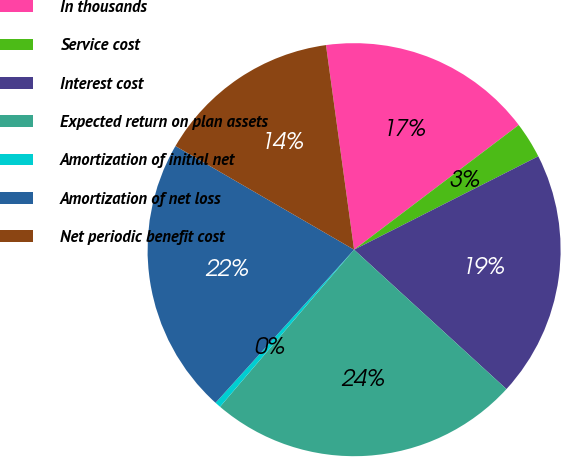Convert chart. <chart><loc_0><loc_0><loc_500><loc_500><pie_chart><fcel>In thousands<fcel>Service cost<fcel>Interest cost<fcel>Expected return on plan assets<fcel>Amortization of initial net<fcel>Amortization of net loss<fcel>Net periodic benefit cost<nl><fcel>16.86%<fcel>2.85%<fcel>19.26%<fcel>24.45%<fcel>0.46%<fcel>21.66%<fcel>14.46%<nl></chart> 